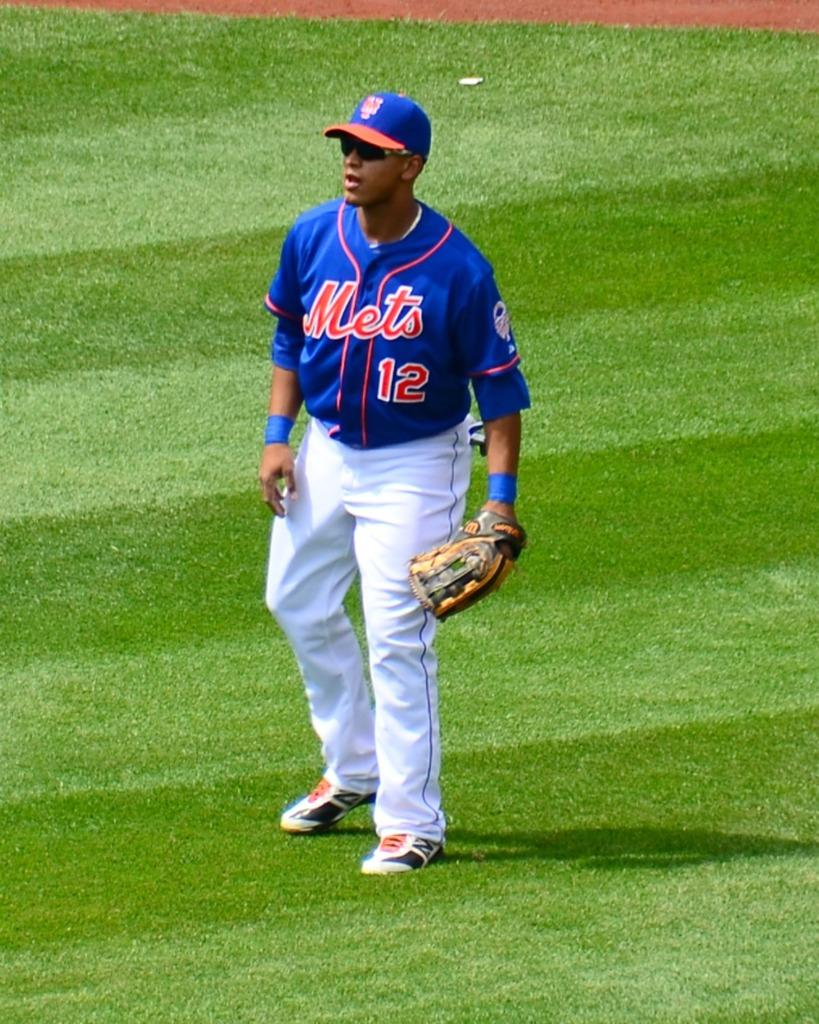Who is present in the image? There is a man in the image. What is the man's position in relation to the ground? The man is standing on the ground. What type of scissors is the man using to cut the geese in the image? There are no scissors or geese present in the image; it only features a man standing on the ground. 